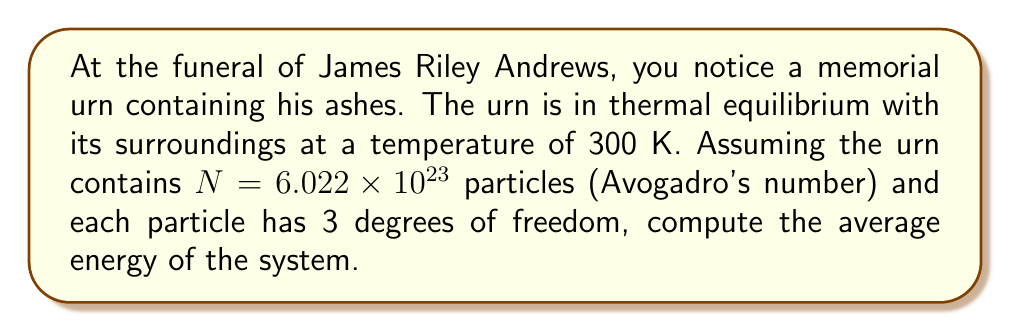Can you answer this question? To solve this problem, we'll use the equipartition theorem from statistical mechanics. The steps are as follows:

1) The equipartition theorem states that in thermal equilibrium, each degree of freedom contributes $\frac{1}{2}k_BT$ to the average energy of the system, where $k_B$ is the Boltzmann constant and $T$ is the temperature.

2) Given:
   - Temperature $T = 300$ K
   - Number of particles $N = 6.022 \times 10^{23}$
   - Degrees of freedom per particle $f = 3$

3) The Boltzmann constant $k_B = 1.380649 \times 10^{-23}$ J/K

4) For each particle, the average energy is:
   $$E_{particle} = f \cdot \frac{1}{2}k_BT = 3 \cdot \frac{1}{2} \cdot 1.380649 \times 10^{-23} \cdot 300$$

5) Simplify:
   $$E_{particle} = 6.212920 \times 10^{-21} \text{ J}$$

6) For the entire system with $N$ particles, the total average energy is:
   $$E_{total} = N \cdot E_{particle} = 6.022 \times 10^{23} \cdot 6.212920 \times 10^{-21}$$

7) Calculate the final result:
   $$E_{total} = 3.741461 \times 10^3 \text{ J}$$
Answer: $3.741 \times 10^3$ J 